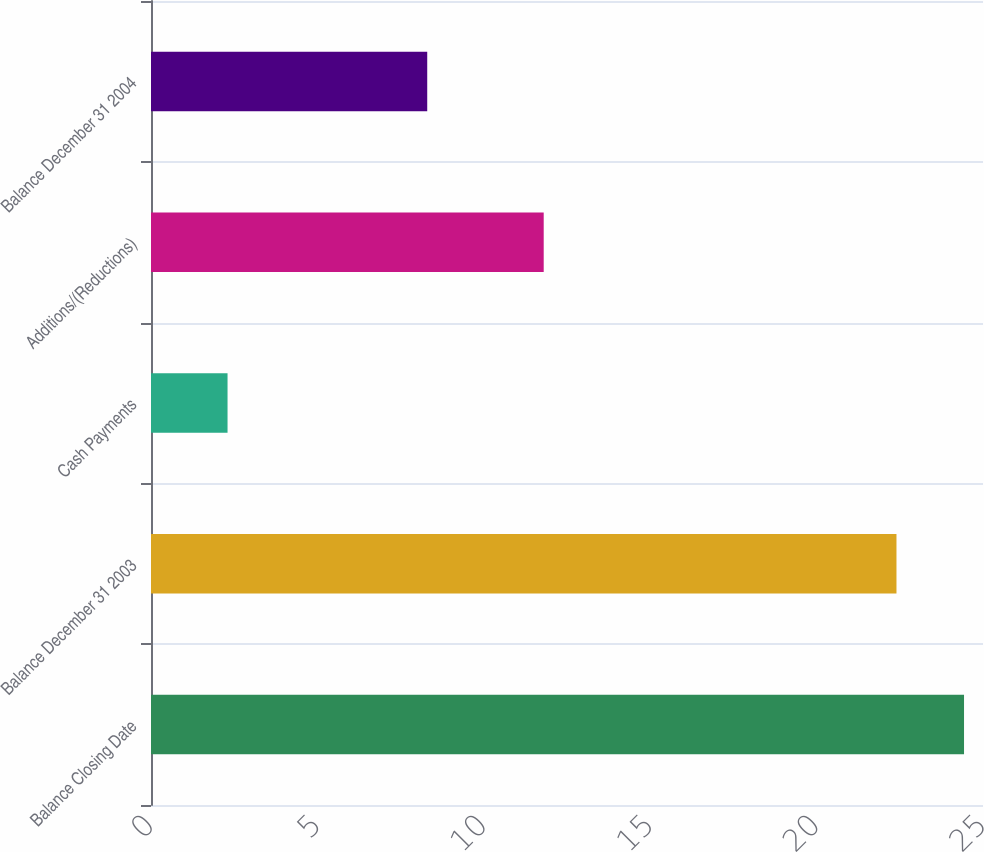<chart> <loc_0><loc_0><loc_500><loc_500><bar_chart><fcel>Balance Closing Date<fcel>Balance December 31 2003<fcel>Cash Payments<fcel>Additions/(Reductions)<fcel>Balance December 31 2004<nl><fcel>24.43<fcel>22.4<fcel>2.3<fcel>11.8<fcel>8.3<nl></chart> 